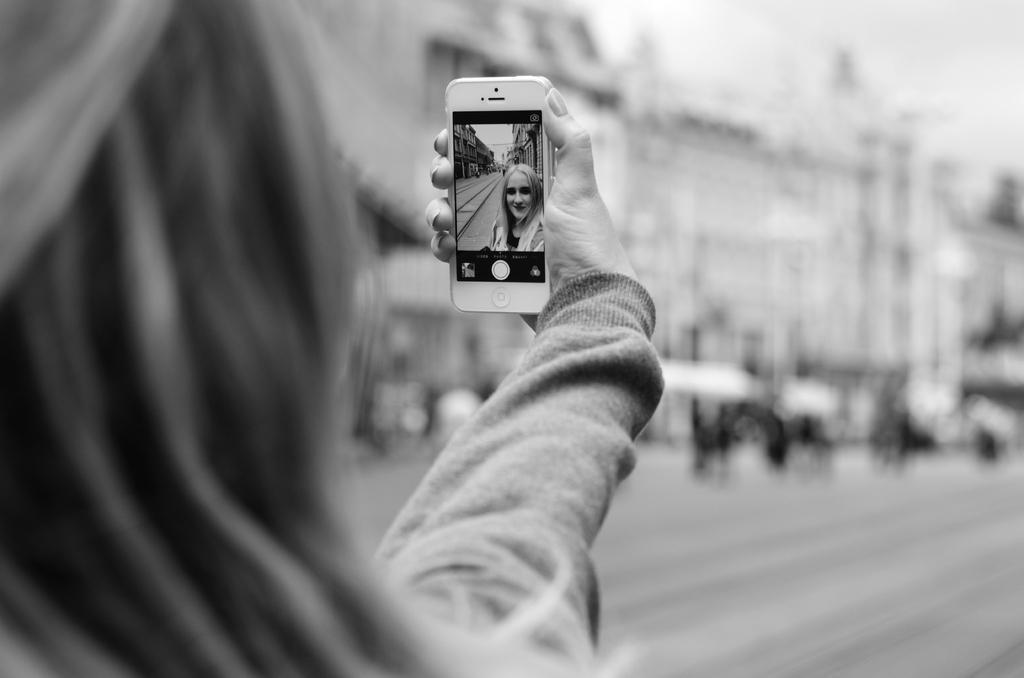Describe this image in one or two sentences. In the given image we can see that a person is catching a device in her hand and taking a selfie. This is a building and there are many other people. 